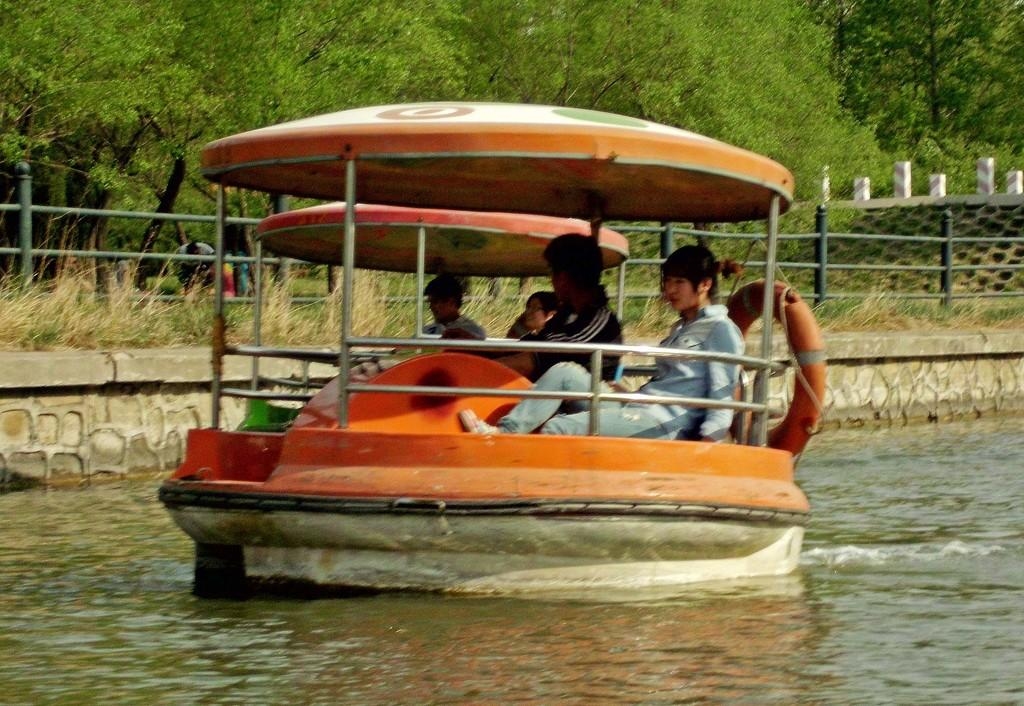What are the people in the image doing? The people in the image are sitting on boats. What can be seen on one of the boats? There is a tube on one of the boats. Where are the boats located? The boats are on the water. What can be seen in the background of the image? There is a railing, grass, and trees in the background. What type of fog can be seen in the image? There is no fog present in the image. What kind of air is being used to power the boats in the image? The boats in the image are not powered by air; they are likely powered by motors or sails. 